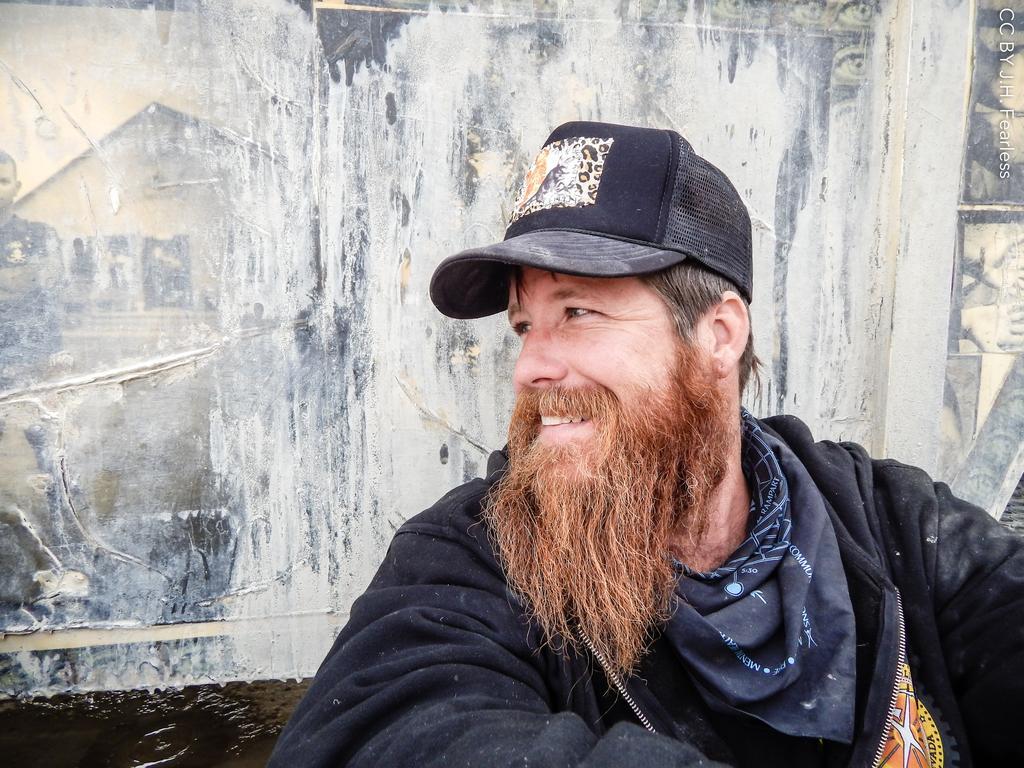Could you give a brief overview of what you see in this image? In this picture I can see there is a man, he is wearing a coat and and he has a mustache and beard. 